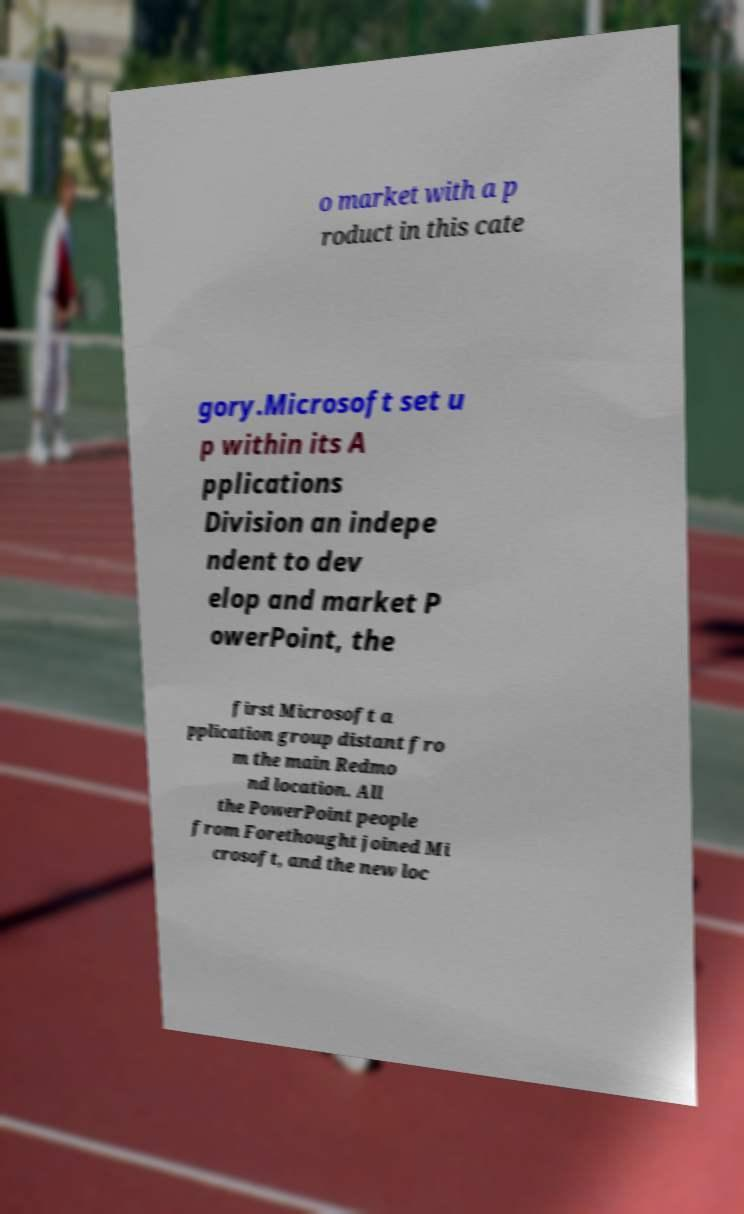Could you assist in decoding the text presented in this image and type it out clearly? o market with a p roduct in this cate gory.Microsoft set u p within its A pplications Division an indepe ndent to dev elop and market P owerPoint, the first Microsoft a pplication group distant fro m the main Redmo nd location. All the PowerPoint people from Forethought joined Mi crosoft, and the new loc 